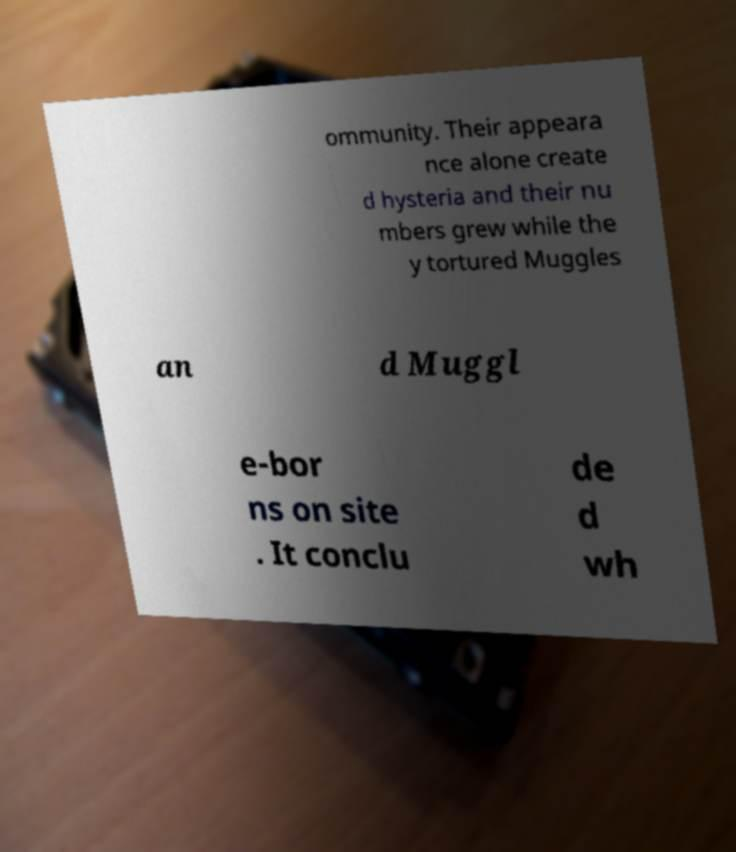What messages or text are displayed in this image? I need them in a readable, typed format. ommunity. Their appeara nce alone create d hysteria and their nu mbers grew while the y tortured Muggles an d Muggl e-bor ns on site . It conclu de d wh 